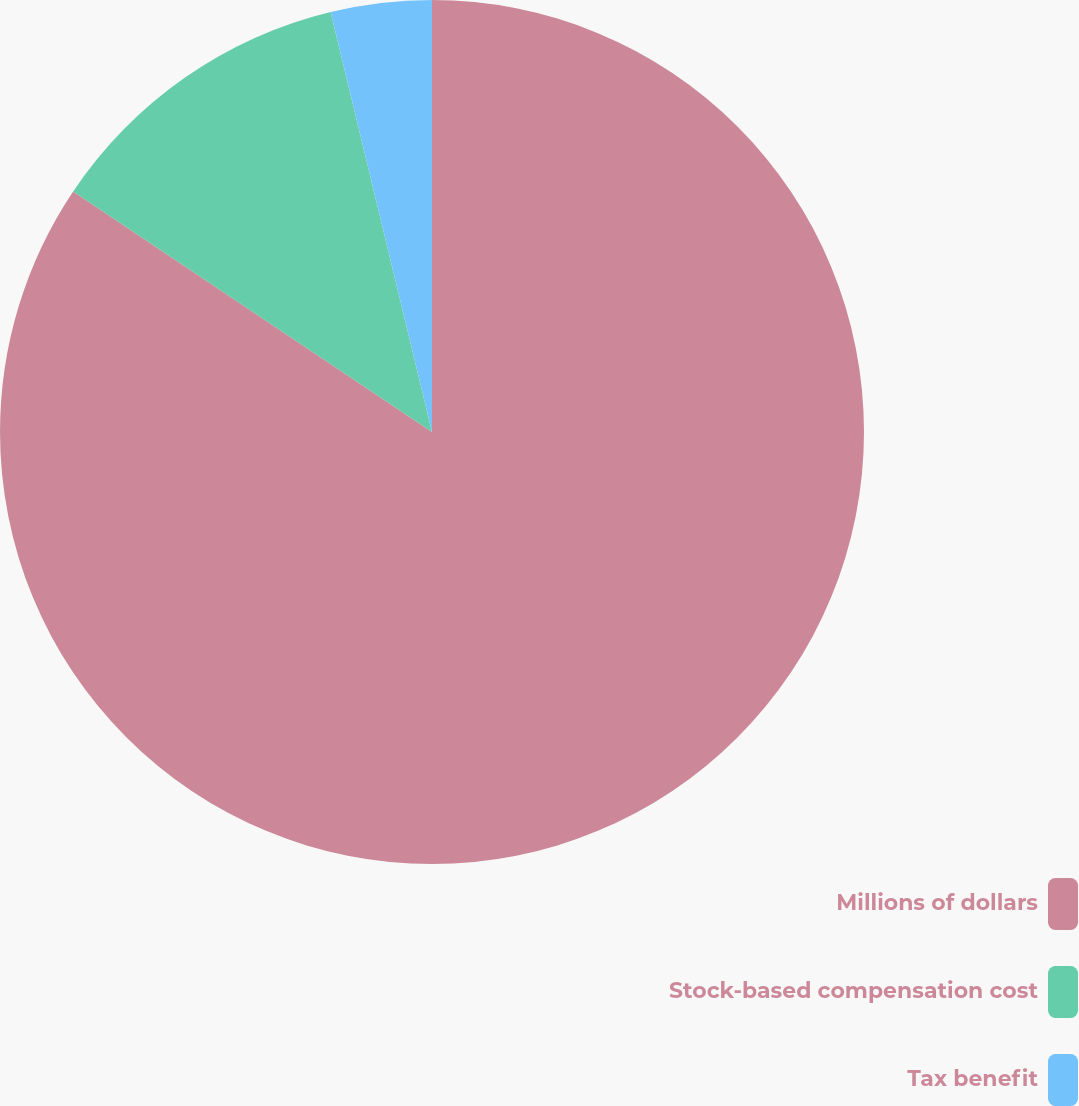Convert chart to OTSL. <chart><loc_0><loc_0><loc_500><loc_500><pie_chart><fcel>Millions of dollars<fcel>Stock-based compensation cost<fcel>Tax benefit<nl><fcel>84.39%<fcel>11.83%<fcel>3.77%<nl></chart> 